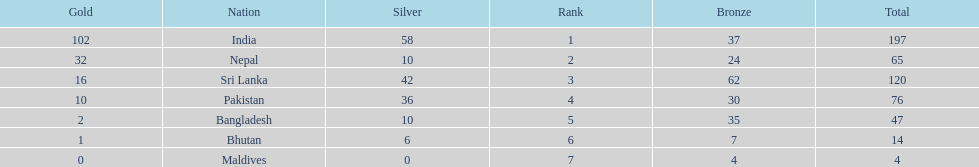Could you parse the entire table as a dict? {'header': ['Gold', 'Nation', 'Silver', 'Rank', 'Bronze', 'Total'], 'rows': [['102', 'India', '58', '1', '37', '197'], ['32', 'Nepal', '10', '2', '24', '65'], ['16', 'Sri Lanka', '42', '3', '62', '120'], ['10', 'Pakistan', '36', '4', '30', '76'], ['2', 'Bangladesh', '10', '5', '35', '47'], ['1', 'Bhutan', '6', '6', '7', '14'], ['0', 'Maldives', '0', '7', '4', '4']]} What are the total number of bronze medals sri lanka have earned? 62. 